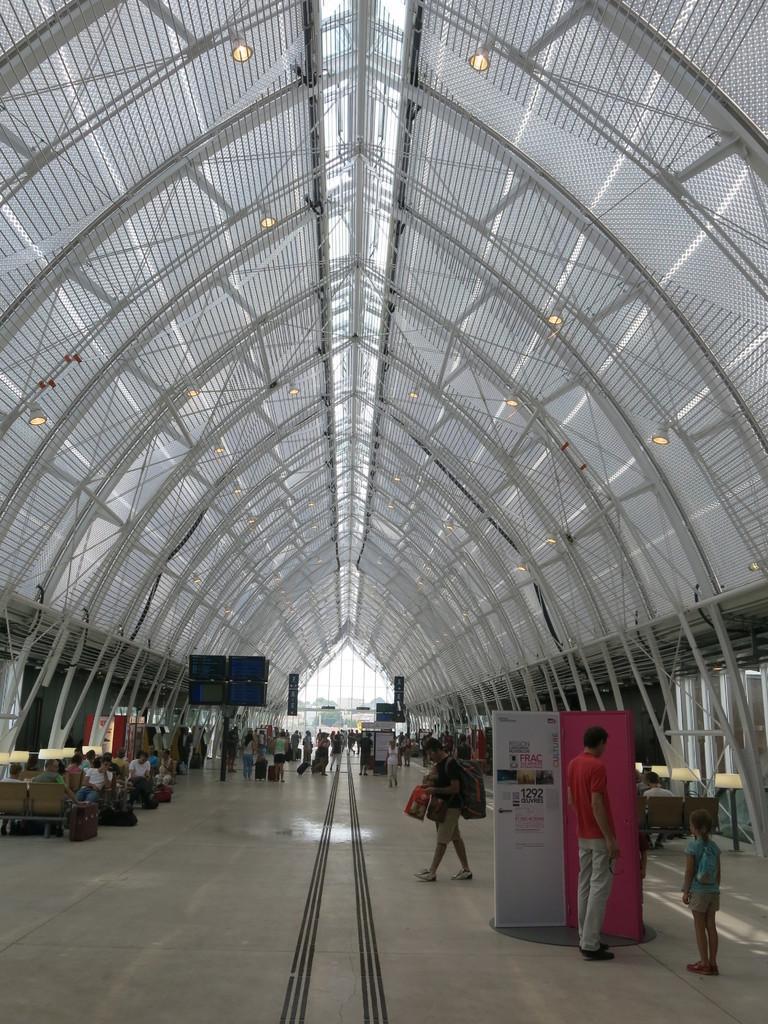Please provide a concise description of this image. This picture describes about group of people, few are standing, few are walking and few are sitting on the chairs, in the background we can see metal rods and lights. 